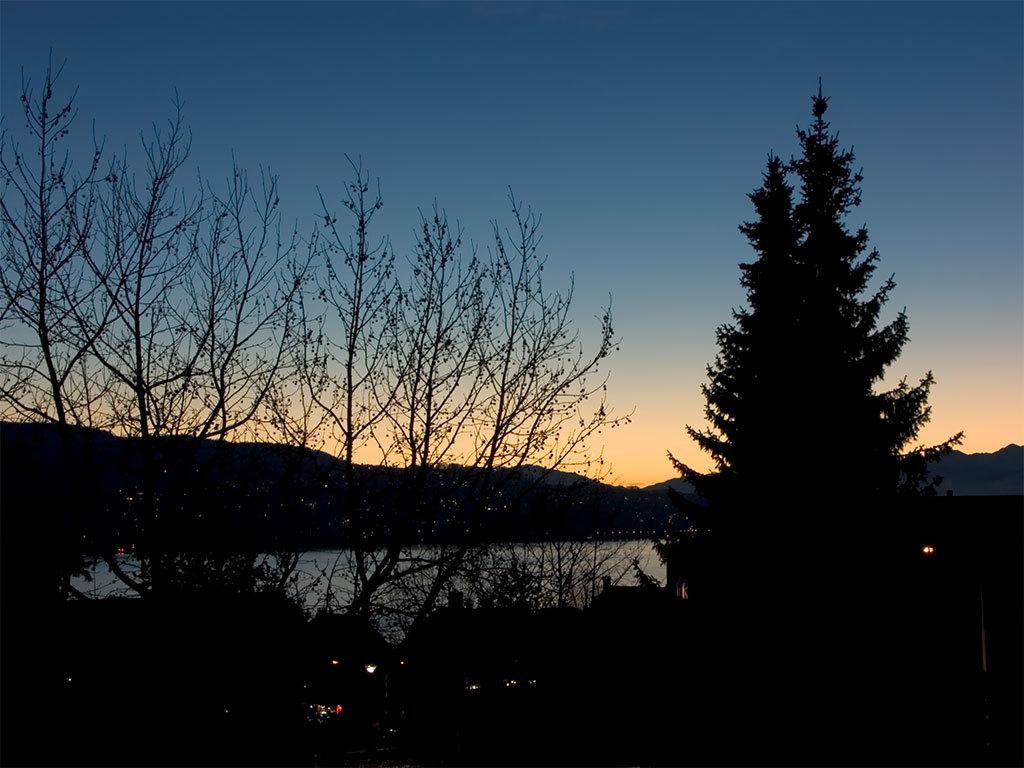What type of vegetation can be seen in the image? There are trees in the image. What else can be seen besides trees in the image? There is water visible in the image. Are there any artificial light sources in the image? Yes, there are lights in the image. How many toes can be seen in the image? There are no toes visible in the image. 